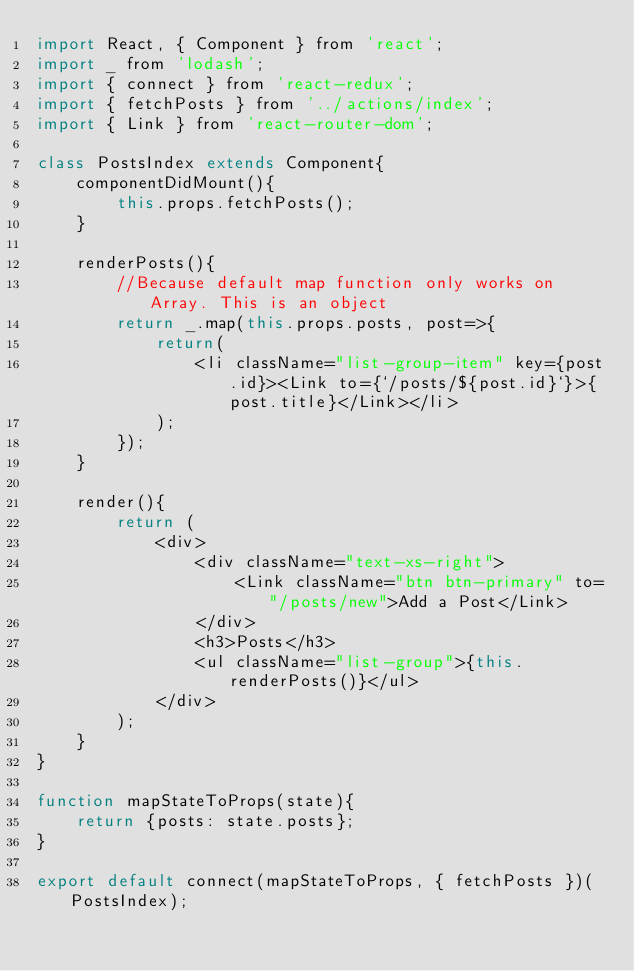<code> <loc_0><loc_0><loc_500><loc_500><_JavaScript_>import React, { Component } from 'react';
import _ from 'lodash';
import { connect } from 'react-redux';
import { fetchPosts } from '../actions/index';
import { Link } from 'react-router-dom';

class PostsIndex extends Component{
    componentDidMount(){
        this.props.fetchPosts();
    }

    renderPosts(){
        //Because default map function only works on Array. This is an object
        return _.map(this.props.posts, post=>{
            return(
                <li className="list-group-item" key={post.id}><Link to={`/posts/${post.id}`}>{post.title}</Link></li>
            );
        });
    }

    render(){
        return (
            <div>
                <div className="text-xs-right">
                    <Link className="btn btn-primary" to="/posts/new">Add a Post</Link>
                </div>
                <h3>Posts</h3>
                <ul className="list-group">{this.renderPosts()}</ul>
            </div>
        );
    }
}

function mapStateToProps(state){
    return {posts: state.posts};
}

export default connect(mapStateToProps, { fetchPosts })(PostsIndex);</code> 